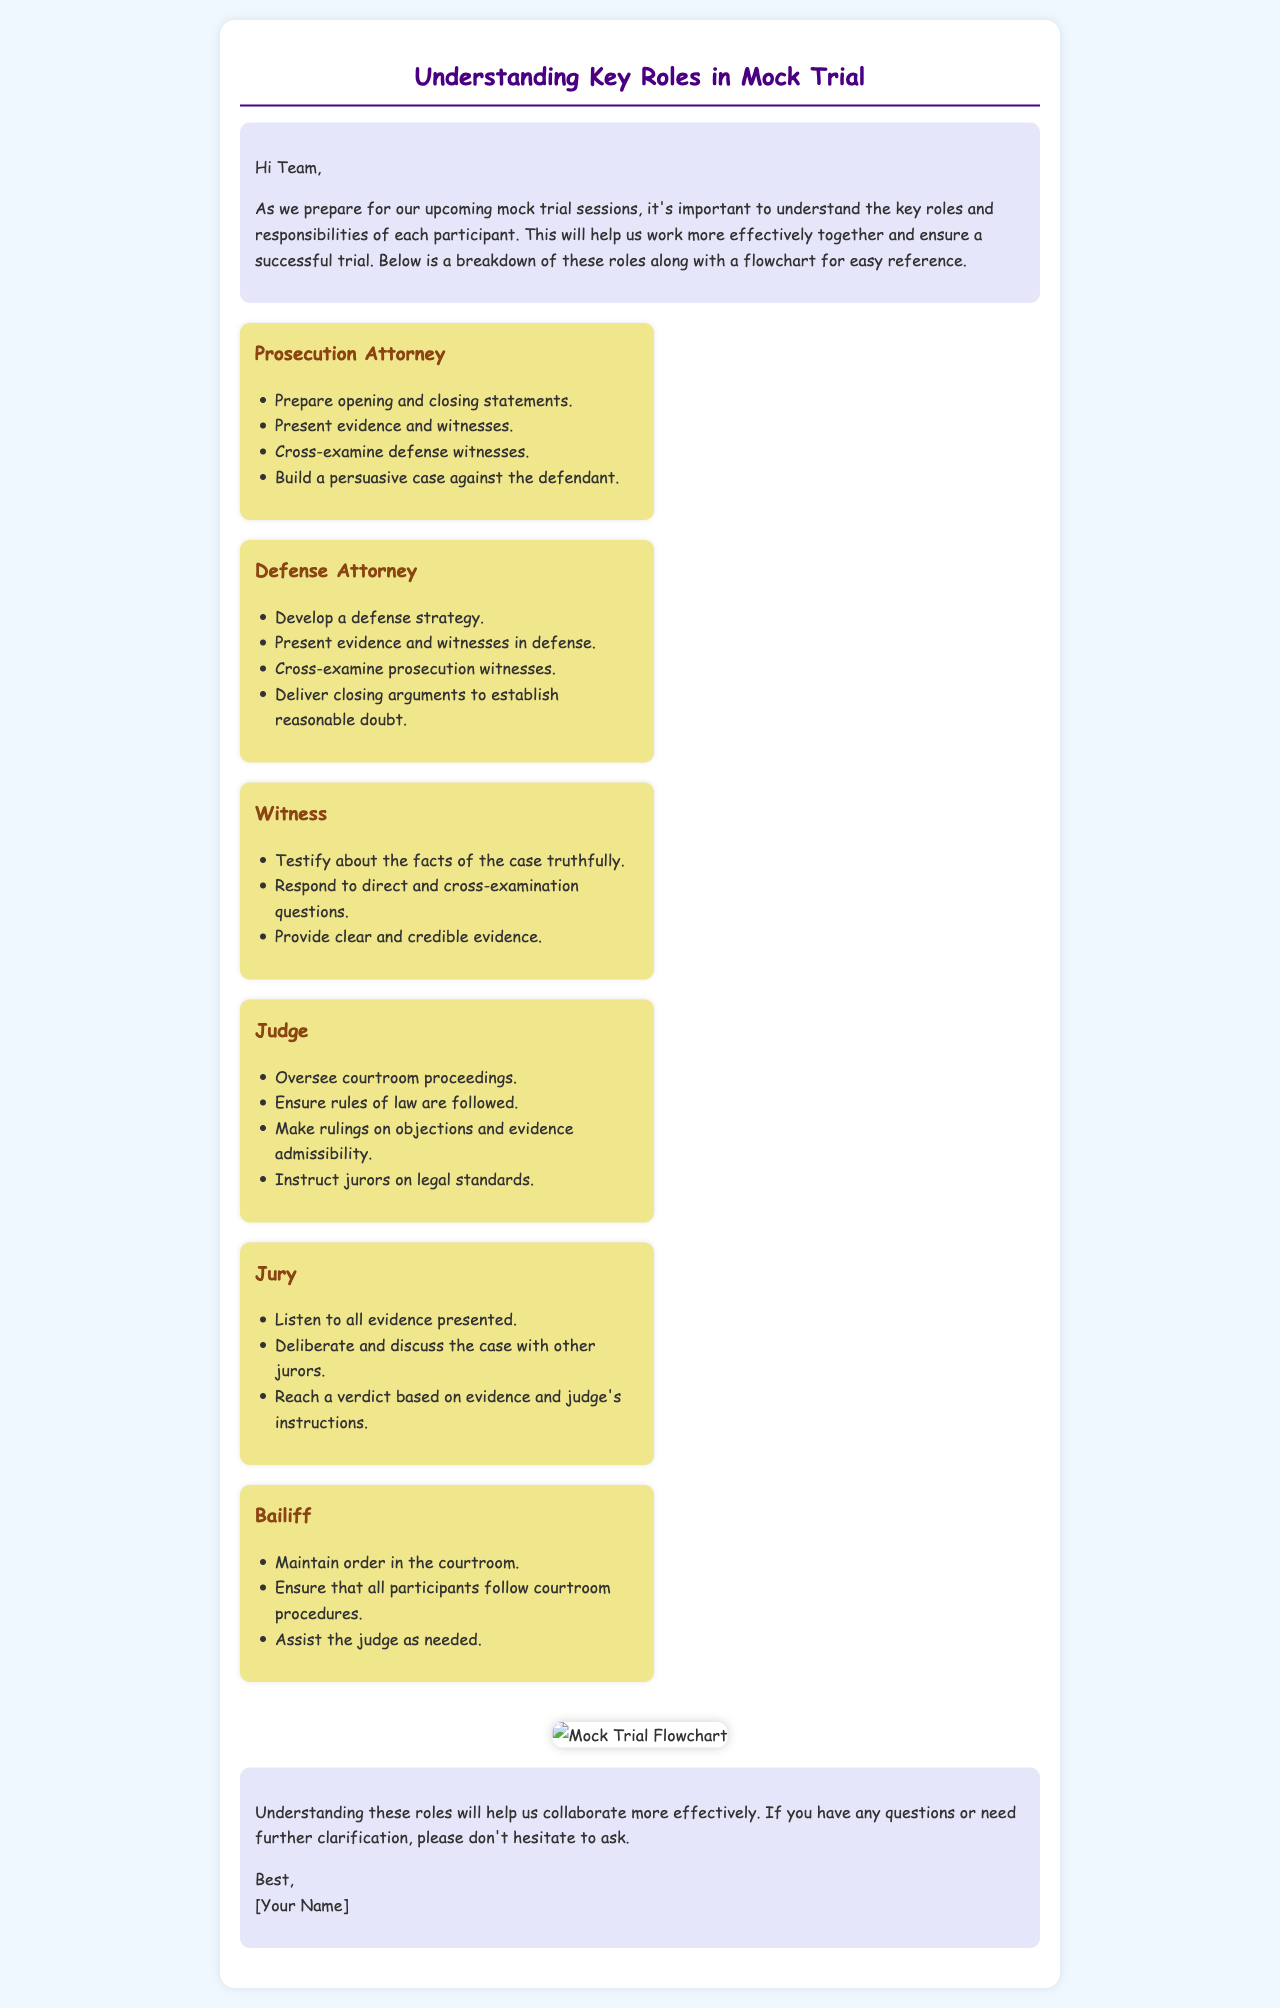What is the role of the Prosecution Attorney? The Prosecution Attorney prepares opening and closing statements, presents evidence and witnesses, cross-examines defense witnesses, and builds a persuasive case against the defendant.
Answer: Prosecution Attorney What does the Defense Attorney need to establish in their closing arguments? The Defense Attorney needs to establish reasonable doubt in their closing arguments.
Answer: Reasonable doubt Who oversees the courtroom proceedings? The Judge oversees the courtroom proceedings, ensuring that rules of law are followed.
Answer: Judge What should witnesses provide during their testimony? Witnesses should provide clear and credible evidence during their testimony.
Answer: Clear and credible evidence Which participant is responsible for maintaining order in the courtroom? The Bailiff is responsible for maintaining order in the courtroom.
Answer: Bailiff How many key roles are outlined in the document? There are six key roles outlined in the document.
Answer: Six What does the Jury do after listening to all the evidence? The Jury deliberates and discusses the case with other jurors to reach a verdict.
Answer: Deliberate and discuss What color is the background of the email document? The background of the email document is a light blue color (#f0f8ff).
Answer: Light blue What is included in the introduction of the email? The introduction includes a greeting and a statement about understanding roles for effective collaboration.
Answer: Greeting and statement about understanding roles 